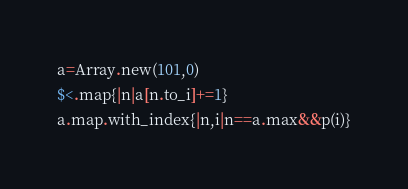<code> <loc_0><loc_0><loc_500><loc_500><_Ruby_>a=Array.new(101,0)
$<.map{|n|a[n.to_i]+=1}
a.map.with_index{|n,i|n==a.max&&p(i)}</code> 